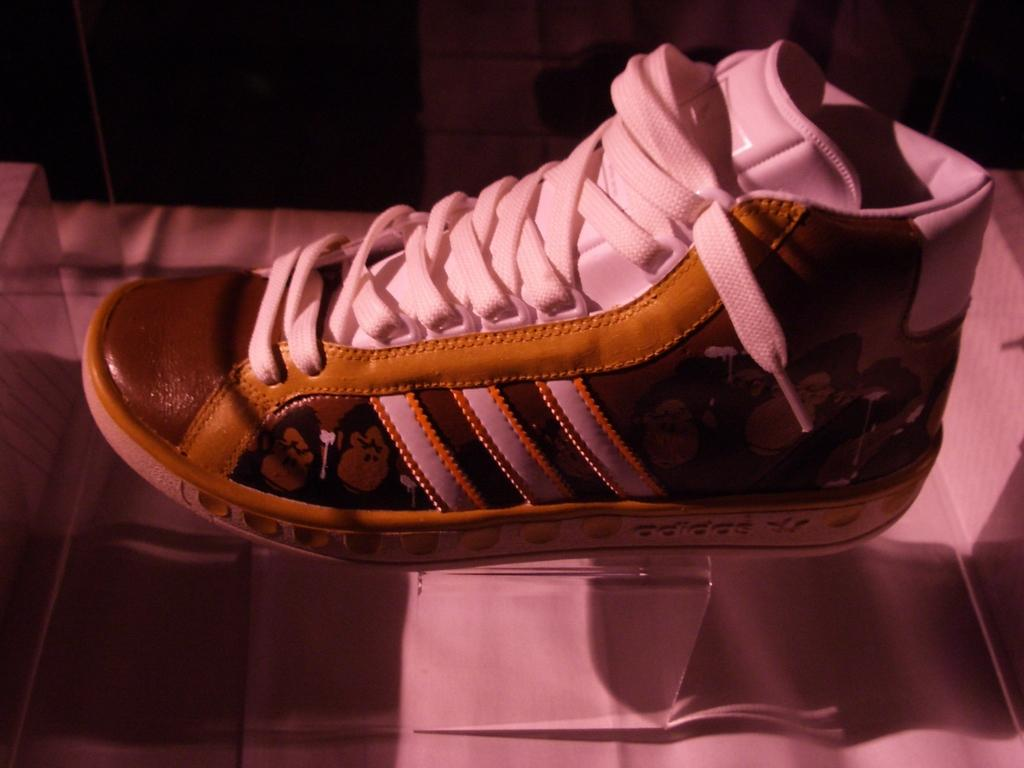What object is the main subject of the image? There is a shoe in the image. Can you describe the surface on which the shoe is placed? The shoe is on a glass surface. What type of canvas is visible on the shoe in the image? There is no canvas visible on the shoe in the image. What type of skin condition can be seen on the shoe in the image? There is no skin condition present on the shoe in the image, as it is an inanimate object. 